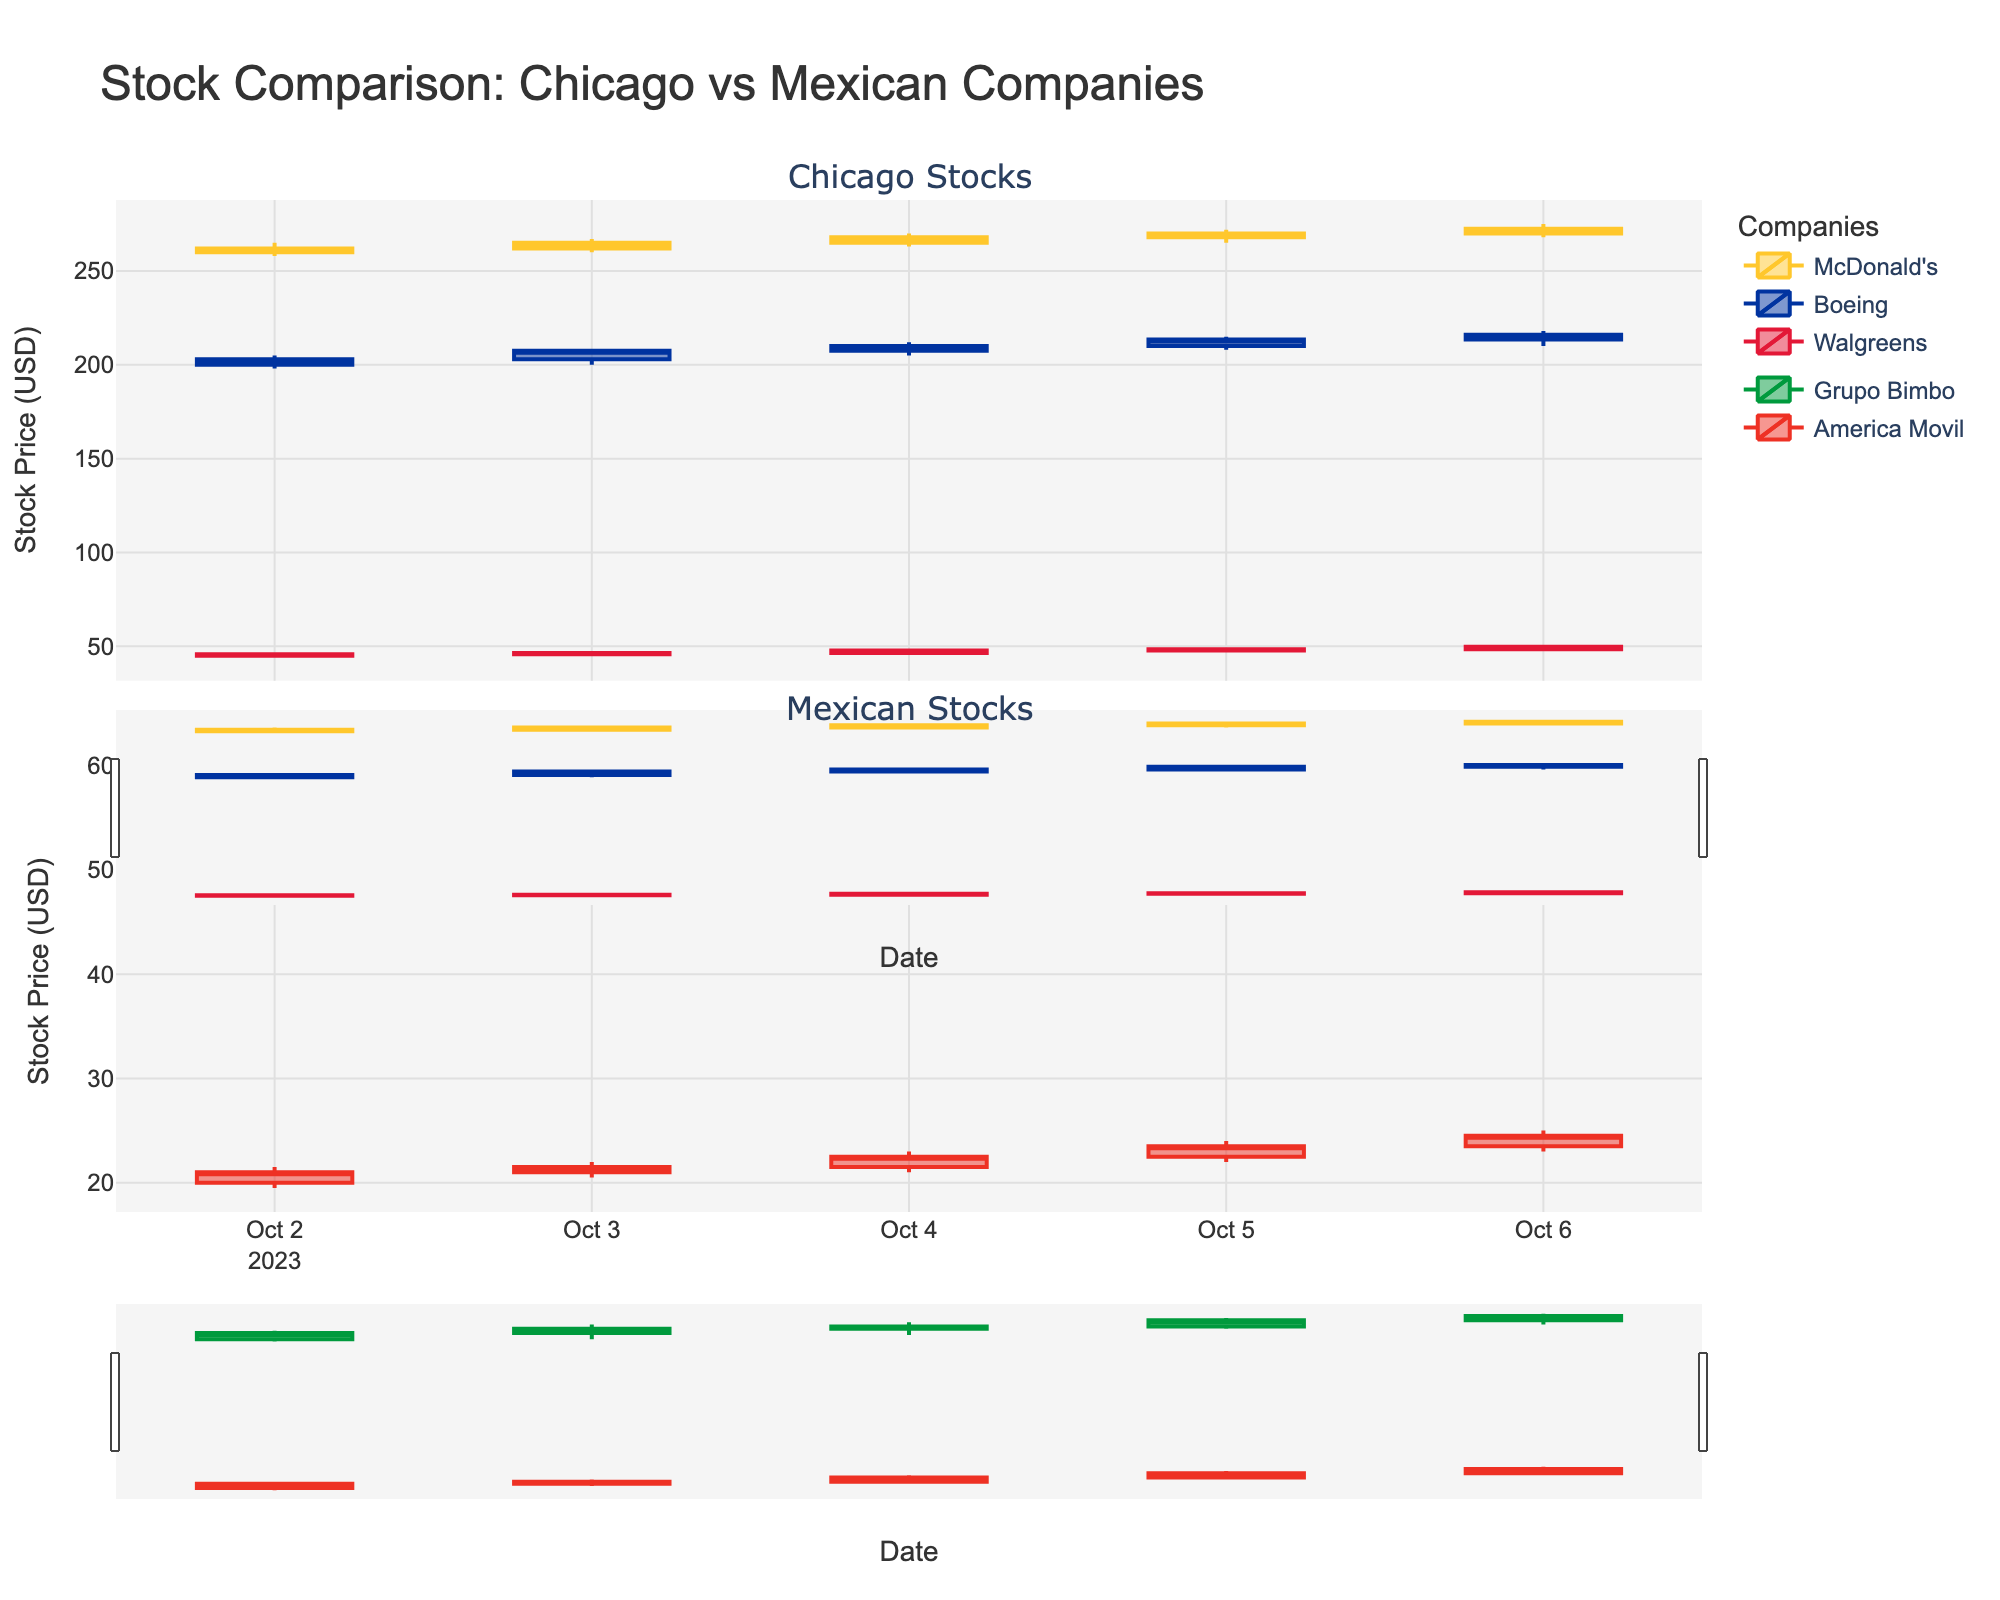What is the title of the figure? The title is displayed prominently at the top of the figure.
Answer: Stock Comparison: Chicago vs Mexican Companies Which company had the highest closing stock price on October 6th? Look at the top subplot for October 6th. McDonald's has the highest closing price of 272.50 USD.
Answer: McDonald's Which company from Chicago showed the largest increase in closing price from October 2nd to October 6th? Calculate the difference in closing prices for McDonald's (272.50 - 262.00 = 10.50), Boeing (216.00 - 203.00 = 13.00), and Walgreens (49.80 - 45.80 = 4.00). Boeing has the largest increase.
Answer: Boeing Between October 2nd and October 6th, which Mexican stock showed a greater increase in stock price: Grupo Bimbo or America Movil? Calculate the difference: Grupo Bimbo (60.50 - 56.50 = 4.00), America Movil (24.50 - 21.00 = 3.50). Grupo Bimbo's increase is greater.
Answer: Grupo Bimbo On October 3rd, which company's stock from Mexico reached the highest high price? Check the high prices for Grupo Bimbo (58.50) and America Movil (22.00). Grupo Bimbo has the highest high price.
Answer: Grupo Bimbo Which company had the highest trading volume on October 4th? Look at the volumes for October 4th. Boeing has the highest volume of 4,550,000 shares.
Answer: Boeing What is the time span of the stock data shown in the figure? The earliest date is October 2nd and the latest date is October 6th, spanning 5 days.
Answer: 5 days Which stock had the highest high price on October 5th? Compare the high prices for all stocks on October 5th. McDonald's has the highest high price of 272 USD.
Answer: McDonald's What was the closing stock price of Walgreens on October 4th? Locate Walgreens' closing price on October 4th in the top subplot. It is 47.80 USD.
Answer: 47.80 How did America Movil's stock price trend from October 2nd to October 6th? Observe the candlestick movements for America Movil in the bottom subplot. The stock price generally increased from a close of 21.00 USD to 24.50 USD.
Answer: Increased 